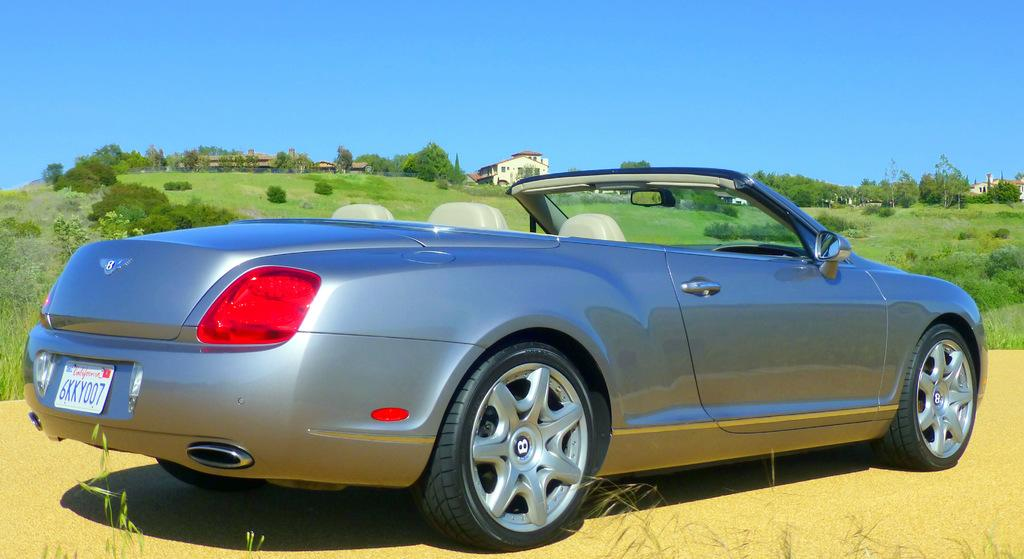What is the main subject of the image? There is a car in the image. What can be seen in the background of the image? There are trees and buildings in the background of the image. What is the ground covered with in the image? The ground appears to be covered in greenery. Where is the stove located in the image? There is no stove present in the image. Can you see the grandmother in the image? There is no grandmother present in the image. 